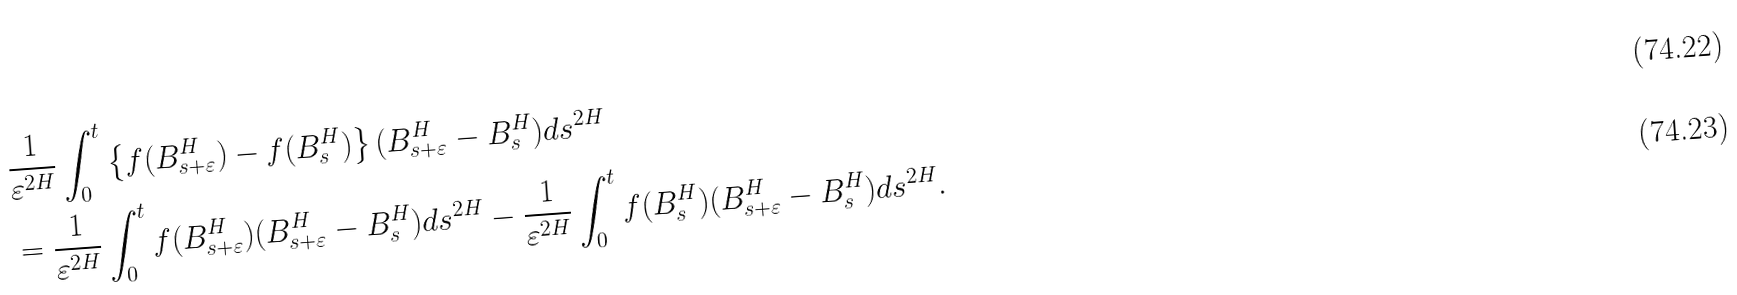<formula> <loc_0><loc_0><loc_500><loc_500>& \frac { 1 } { \varepsilon ^ { 2 H } } \int _ { 0 } ^ { t } \left \{ f ( B ^ { H } _ { s + \varepsilon } ) - f ( B ^ { H } _ { s } ) \right \} ( B ^ { H } _ { s + \varepsilon } - B ^ { H } _ { s } ) d s ^ { 2 H } \\ & = \frac { 1 } { \varepsilon ^ { 2 H } } \int _ { 0 } ^ { t } f ( B ^ { H } _ { s + \varepsilon } ) ( B ^ { H } _ { s + \varepsilon } - B ^ { H } _ { s } ) d s ^ { 2 H } - \frac { 1 } { \varepsilon ^ { 2 H } } \int _ { 0 } ^ { t } f ( B ^ { H } _ { s } ) ( B ^ { H } _ { s + \varepsilon } - B ^ { H } _ { s } ) d s ^ { 2 H } .</formula> 